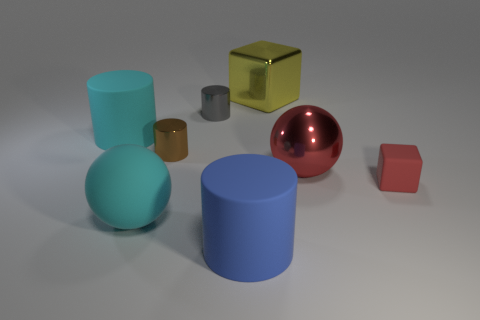Subtract all brown cylinders. How many cylinders are left? 3 Add 1 small red matte things. How many objects exist? 9 Subtract all cyan cylinders. How many cylinders are left? 3 Subtract all spheres. How many objects are left? 6 Add 4 red cubes. How many red cubes are left? 5 Add 5 cyan matte cylinders. How many cyan matte cylinders exist? 6 Subtract 0 purple balls. How many objects are left? 8 Subtract all red cubes. Subtract all yellow cylinders. How many cubes are left? 1 Subtract all tiny cylinders. Subtract all tiny red matte objects. How many objects are left? 5 